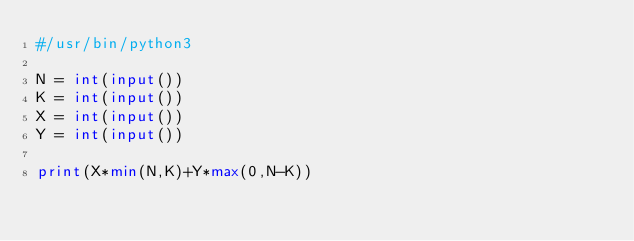Convert code to text. <code><loc_0><loc_0><loc_500><loc_500><_Python_>#/usr/bin/python3

N = int(input())
K = int(input())
X = int(input())
Y = int(input())

print(X*min(N,K)+Y*max(0,N-K))
</code> 